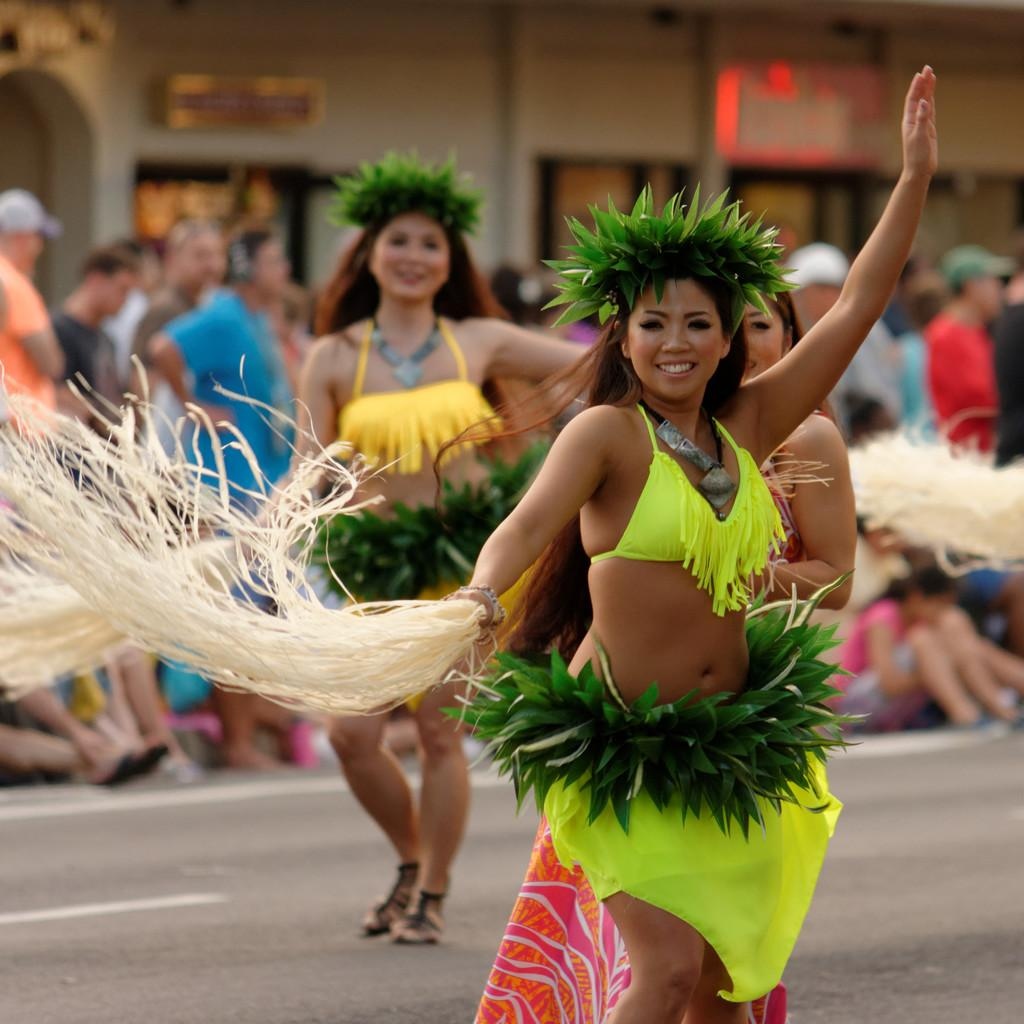How many persons are in the image? There are persons in the image. What can be observed about the clothing of the persons? The persons are wearing different color dresses. What is the facial expression of the persons? The persons are smiling. What activity are the persons engaged in? The persons are dancing. What is visible in the background of the image? The road is visible in the image. What can be seen on the road? There are white color marks on the road. What type of soup is being served on the tray in the image? There is no tray or soup present in the image. How many tomatoes are visible on the persons' dresses in the image? There are no tomatoes visible on the persons' dresses in the image. 